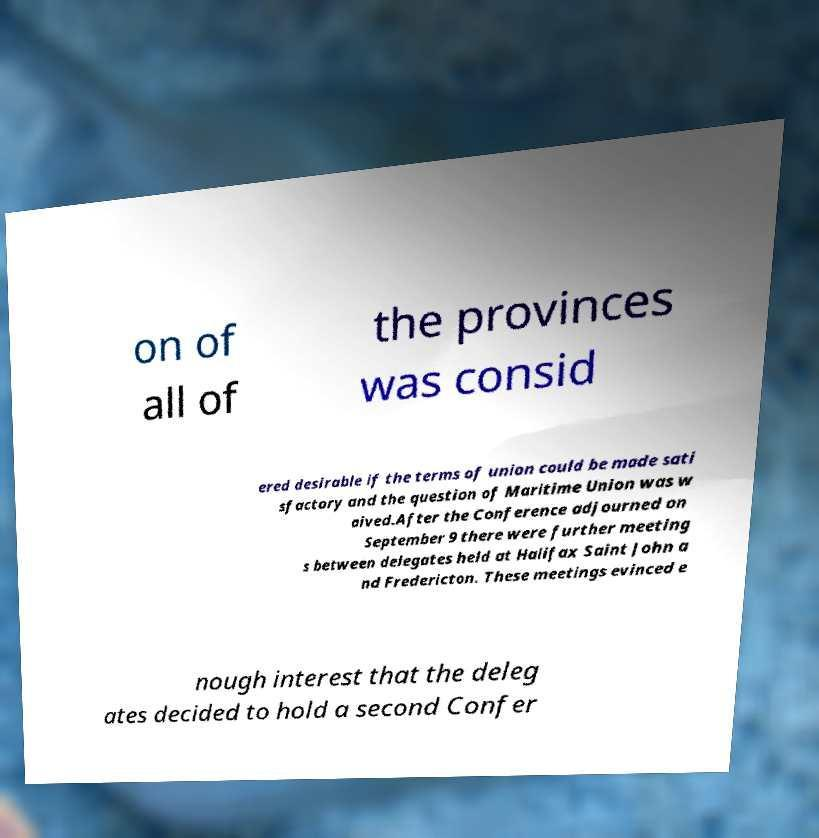Can you accurately transcribe the text from the provided image for me? on of all of the provinces was consid ered desirable if the terms of union could be made sati sfactory and the question of Maritime Union was w aived.After the Conference adjourned on September 9 there were further meeting s between delegates held at Halifax Saint John a nd Fredericton. These meetings evinced e nough interest that the deleg ates decided to hold a second Confer 